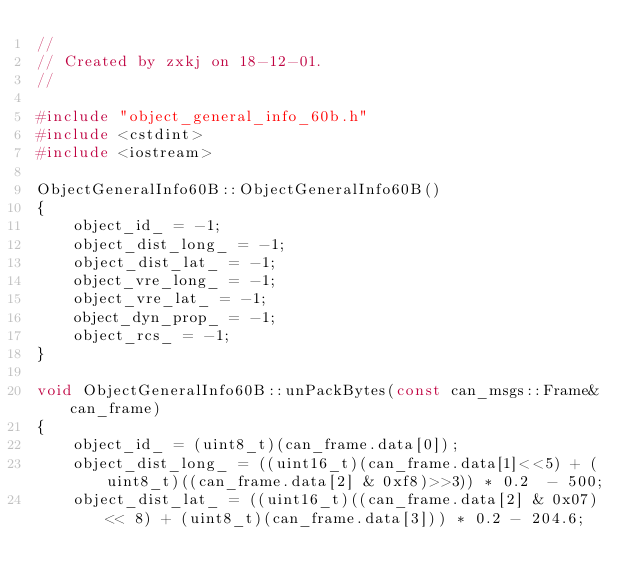<code> <loc_0><loc_0><loc_500><loc_500><_C++_>//
// Created by zxkj on 18-12-01.
//

#include "object_general_info_60b.h"
#include <cstdint>
#include <iostream>

ObjectGeneralInfo60B::ObjectGeneralInfo60B()
{
    object_id_ = -1;
    object_dist_long_ = -1;
    object_dist_lat_ = -1;
    object_vre_long_ = -1;
    object_vre_lat_ = -1;
    object_dyn_prop_ = -1;
    object_rcs_ = -1;    
}

void ObjectGeneralInfo60B::unPackBytes(const can_msgs::Frame& can_frame)
{
    object_id_ = (uint8_t)(can_frame.data[0]);
    object_dist_long_ = ((uint16_t)(can_frame.data[1]<<5) + (uint8_t)((can_frame.data[2] & 0xf8)>>3)) * 0.2  - 500;
    object_dist_lat_ = ((uint16_t)((can_frame.data[2] & 0x07) << 8) + (uint8_t)(can_frame.data[3])) * 0.2 - 204.6;</code> 